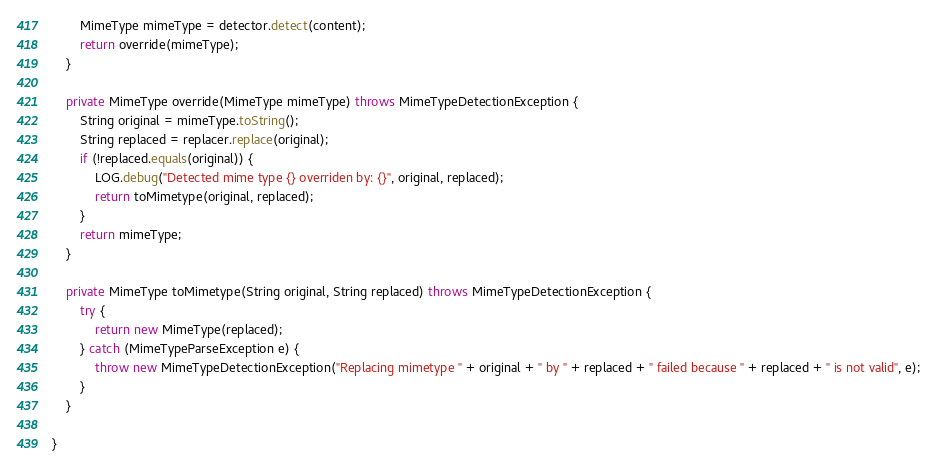Convert code to text. <code><loc_0><loc_0><loc_500><loc_500><_Java_>		MimeType mimeType = detector.detect(content);
		return override(mimeType);
	}

	private MimeType override(MimeType mimeType) throws MimeTypeDetectionException {
		String original = mimeType.toString();
		String replaced = replacer.replace(original);
		if (!replaced.equals(original)) {
			LOG.debug("Detected mime type {} overriden by: {}", original, replaced);
			return toMimetype(original, replaced);
		}
		return mimeType;
	}

	private MimeType toMimetype(String original, String replaced) throws MimeTypeDetectionException {
		try {
			return new MimeType(replaced);
		} catch (MimeTypeParseException e) {
			throw new MimeTypeDetectionException("Replacing mimetype " + original + " by " + replaced + " failed because " + replaced + " is not valid", e);
		}
	}

}
</code> 